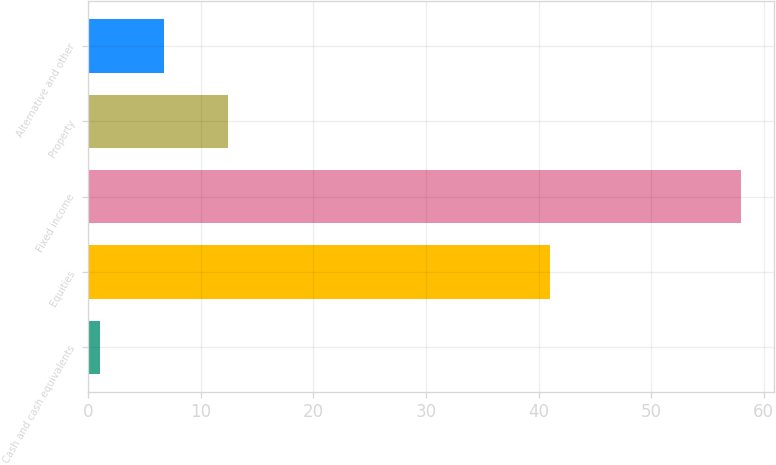Convert chart. <chart><loc_0><loc_0><loc_500><loc_500><bar_chart><fcel>Cash and cash equivalents<fcel>Equities<fcel>Fixed income<fcel>Property<fcel>Alternative and other<nl><fcel>1<fcel>41<fcel>58<fcel>12.4<fcel>6.7<nl></chart> 